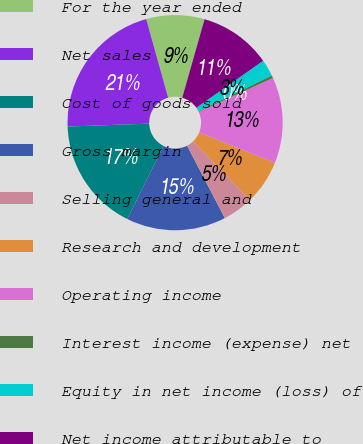<chart> <loc_0><loc_0><loc_500><loc_500><pie_chart><fcel>For the year ended<fcel>Net sales<fcel>Cost of goods sold<fcel>Gross margin<fcel>Selling general and<fcel>Research and development<fcel>Operating income<fcel>Interest income (expense) net<fcel>Equity in net income (loss) of<fcel>Net income attributable to<nl><fcel>8.75%<fcel>21.24%<fcel>17.08%<fcel>14.99%<fcel>4.59%<fcel>6.67%<fcel>12.91%<fcel>0.43%<fcel>2.51%<fcel>10.83%<nl></chart> 